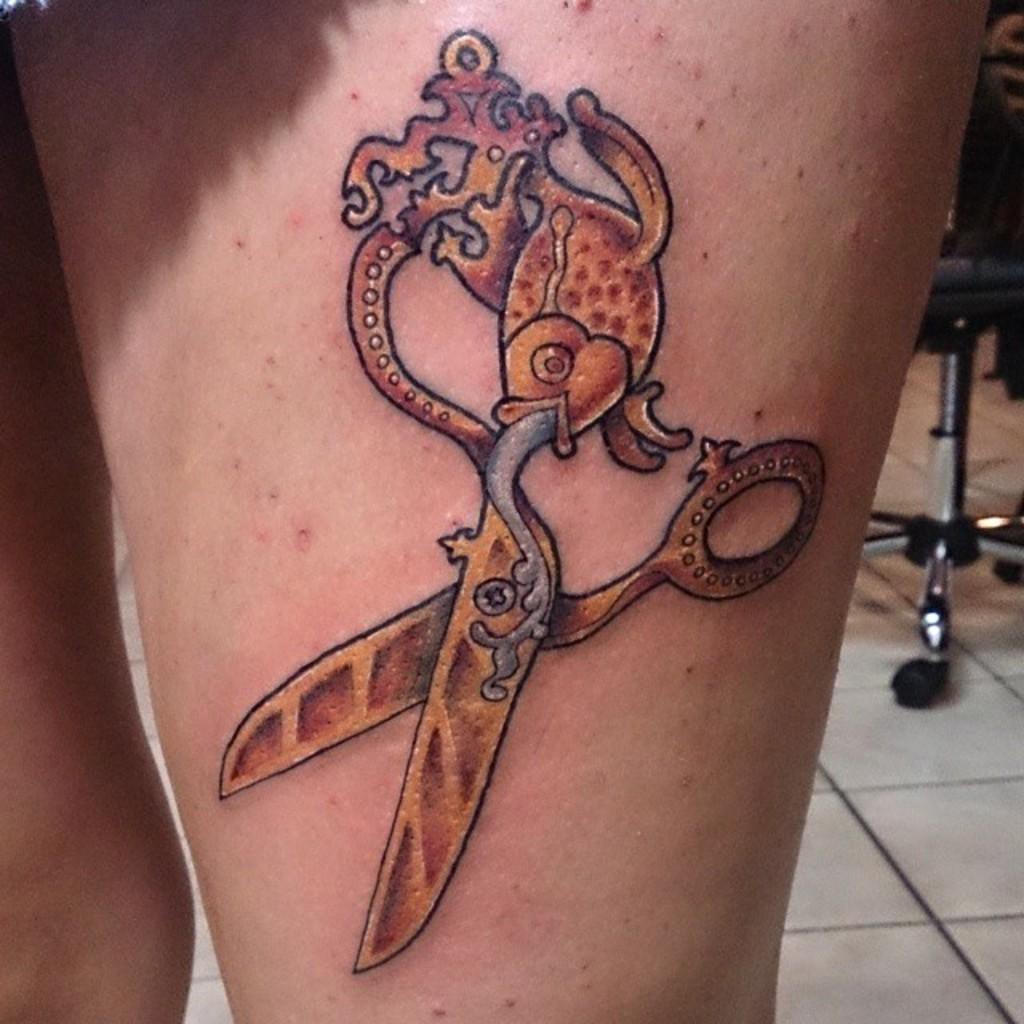What is present on a leg in the image? There is a tattoo on a leg in the image. What can be seen at the bottom of the image? There is a floor visible at the bottom of the image. What piece of furniture is located on the right side of the image? There is a chair on the right side of the image. How many circles can be seen in the tattoo on the leg in the image? There is no information about circles in the tattoo on the leg in the image; we can only describe the presence of the tattoo itself. 